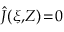Convert formula to latex. <formula><loc_0><loc_0><loc_500><loc_500>\hat { J } ( \xi , \, Z ) \, = \, 0</formula> 